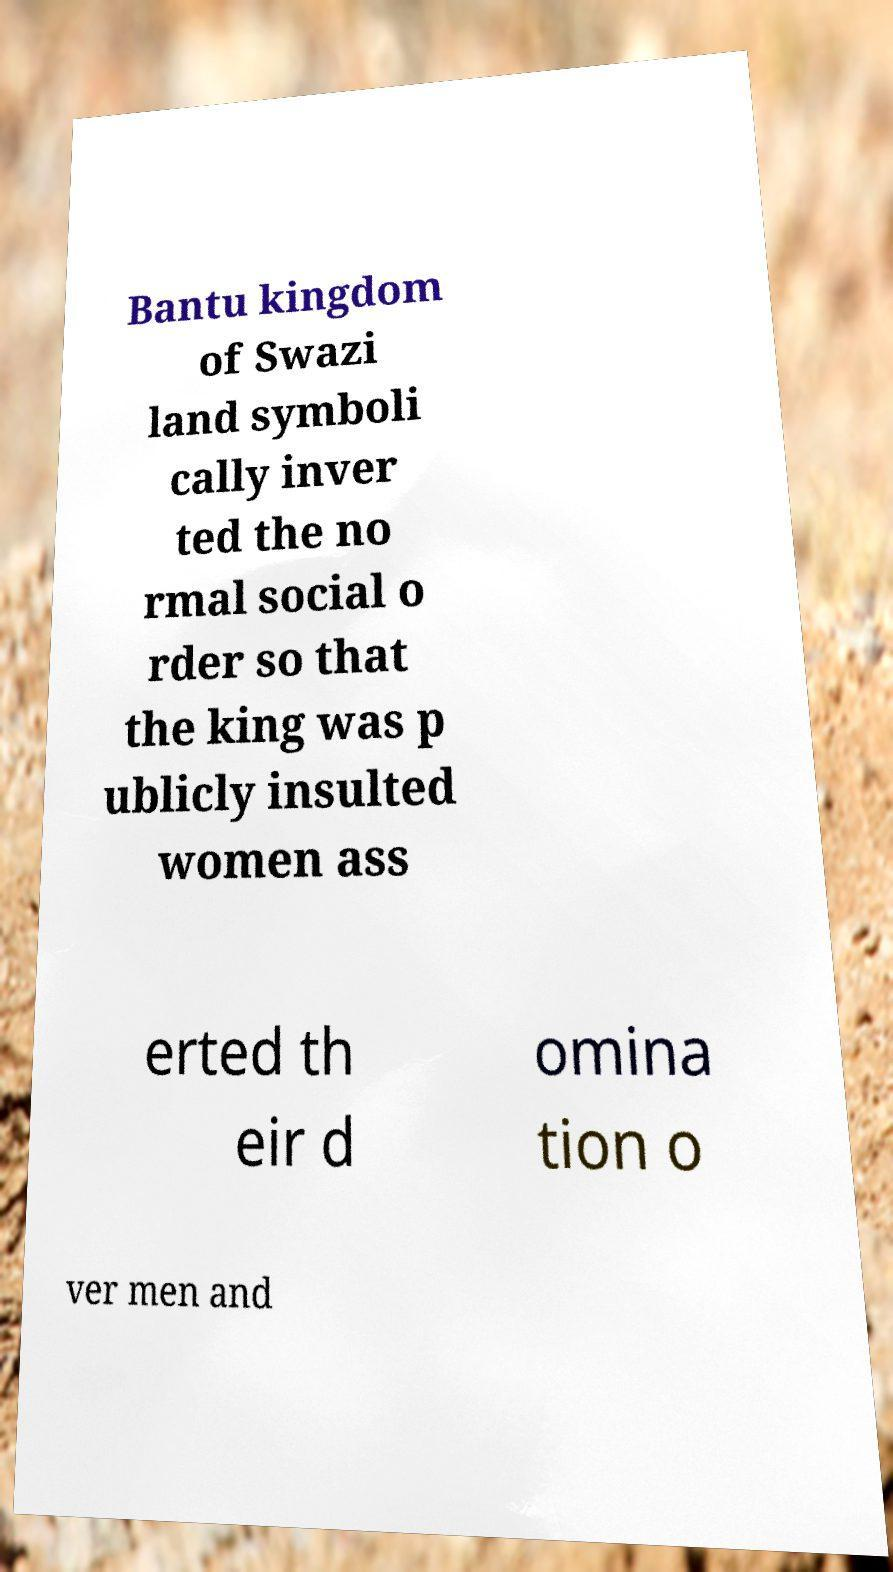Could you extract and type out the text from this image? Bantu kingdom of Swazi land symboli cally inver ted the no rmal social o rder so that the king was p ublicly insulted women ass erted th eir d omina tion o ver men and 